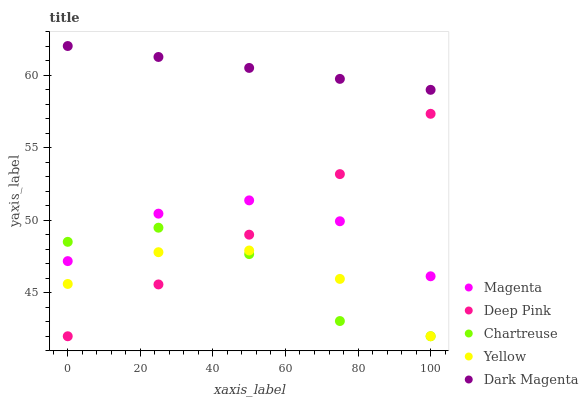Does Chartreuse have the minimum area under the curve?
Answer yes or no. Yes. Does Dark Magenta have the maximum area under the curve?
Answer yes or no. Yes. Does Deep Pink have the minimum area under the curve?
Answer yes or no. No. Does Deep Pink have the maximum area under the curve?
Answer yes or no. No. Is Dark Magenta the smoothest?
Answer yes or no. Yes. Is Chartreuse the roughest?
Answer yes or no. Yes. Is Deep Pink the smoothest?
Answer yes or no. No. Is Deep Pink the roughest?
Answer yes or no. No. Does Deep Pink have the lowest value?
Answer yes or no. Yes. Does Dark Magenta have the lowest value?
Answer yes or no. No. Does Dark Magenta have the highest value?
Answer yes or no. Yes. Does Deep Pink have the highest value?
Answer yes or no. No. Is Yellow less than Dark Magenta?
Answer yes or no. Yes. Is Magenta greater than Yellow?
Answer yes or no. Yes. Does Deep Pink intersect Magenta?
Answer yes or no. Yes. Is Deep Pink less than Magenta?
Answer yes or no. No. Is Deep Pink greater than Magenta?
Answer yes or no. No. Does Yellow intersect Dark Magenta?
Answer yes or no. No. 